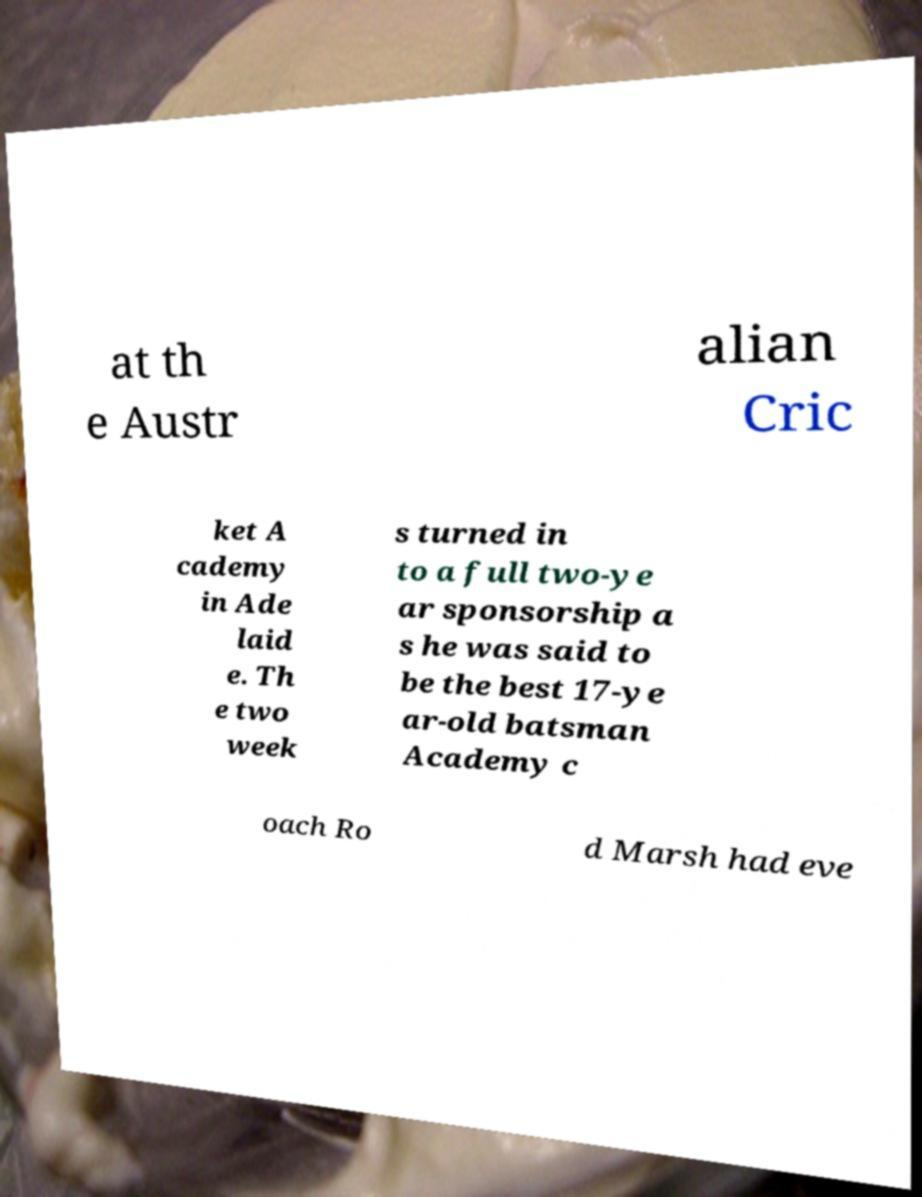Please identify and transcribe the text found in this image. at th e Austr alian Cric ket A cademy in Ade laid e. Th e two week s turned in to a full two-ye ar sponsorship a s he was said to be the best 17-ye ar-old batsman Academy c oach Ro d Marsh had eve 